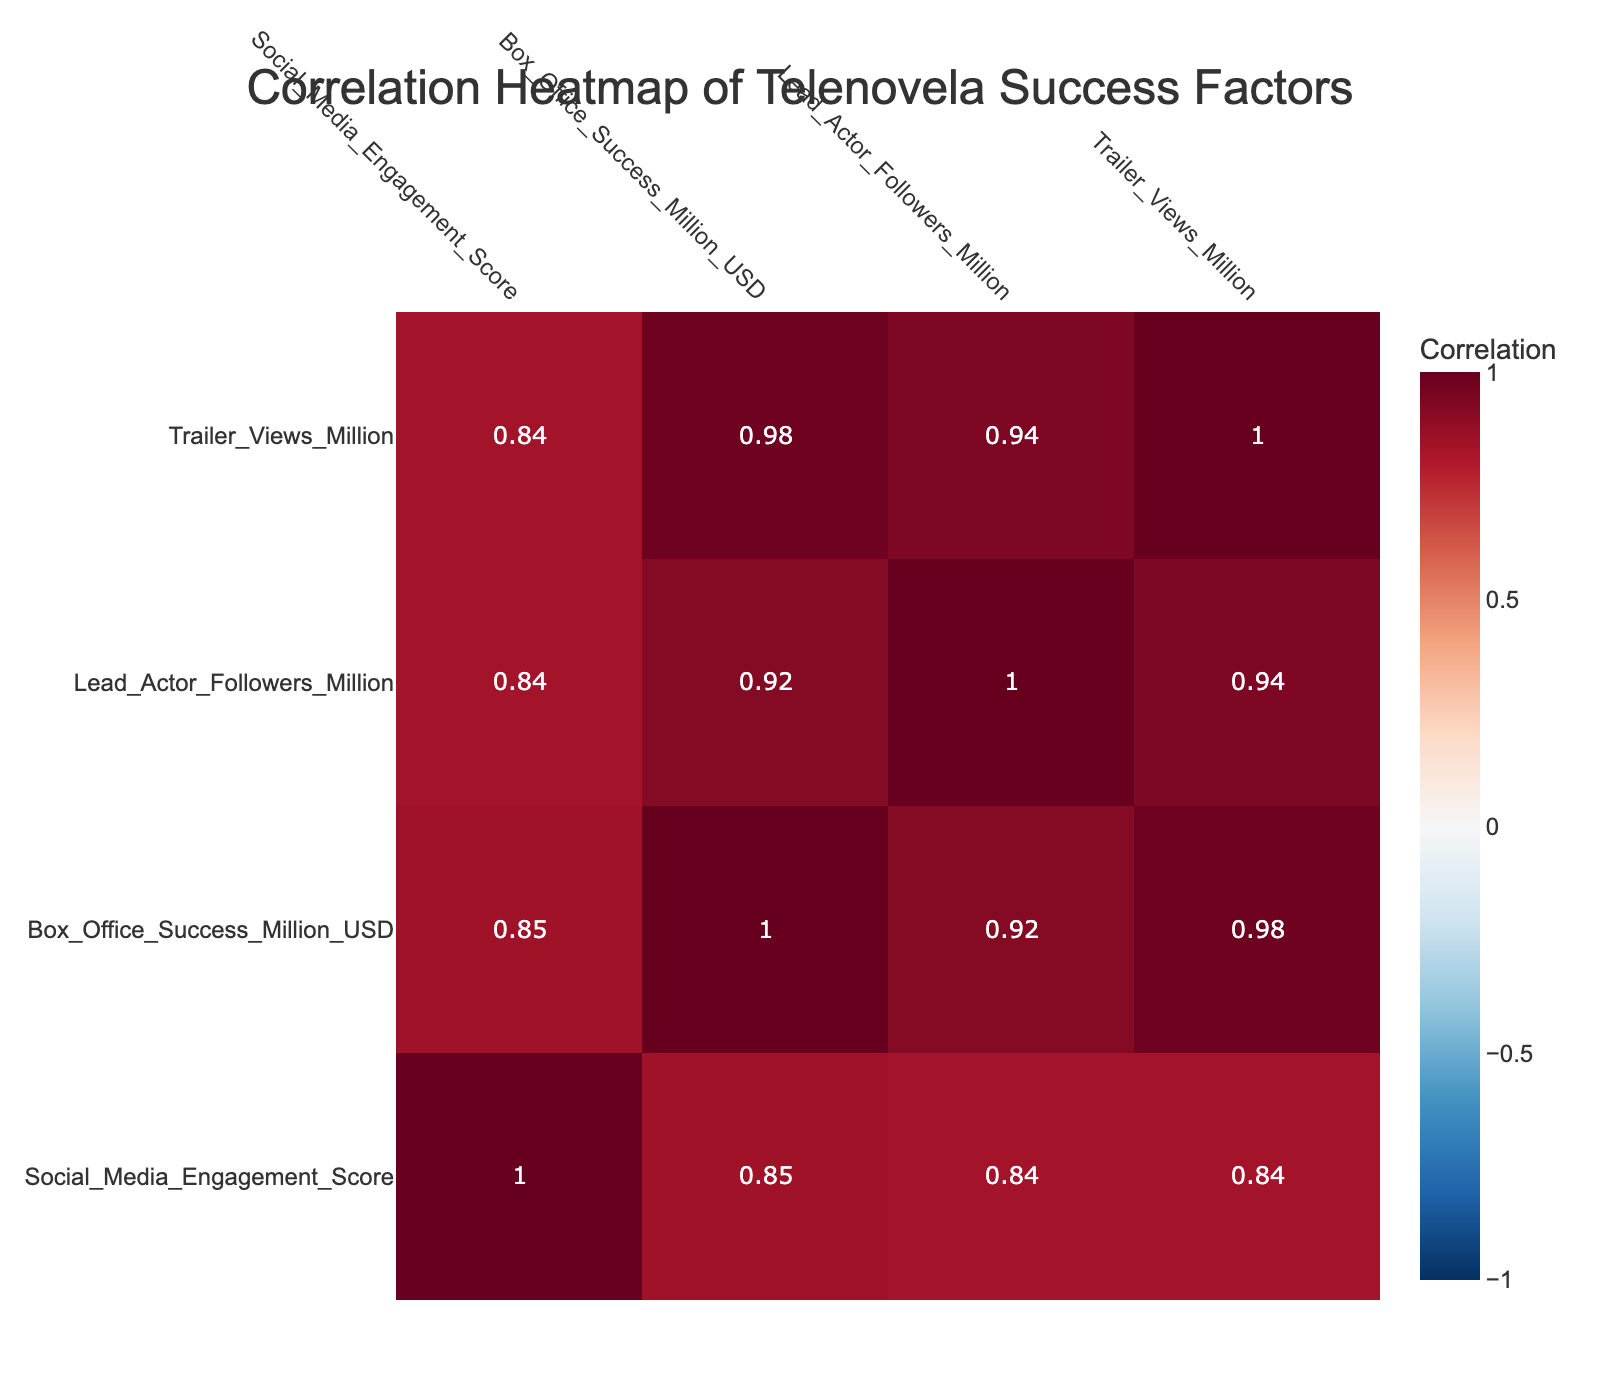What is the Box Office Success of "Amor Eterno"? From the table, we can look for the row corresponding to "Amor Eterno" and find the value under the "Box Office Success Million USD" column, which is 12.0.
Answer: 12.0 What is the correlation between Social Media Engagement Score and Box Office Success? To find the correlation between Social Media Engagement Score and Box Office Success, we observe the correlation matrix values, which shows a coefficient around 0.83. This indicates a strong positive correlation.
Answer: 0.83 Which telenovela has the highest Trailer Views? We compare the "Trailer Views Million" values for all telenovelas, and we see that "Bailando_en_La_Luna" has the highest value at 3.0 million views.
Answer: Bailando_en_La_Luna Is the correlation between Lead Actor Followers and Box Office Success positive? Referring to the correlation matrix, we can see the correlation coefficient between Lead Actor Followers and Box Office Success is 0.70, indicating a positive correlation.
Answer: Yes What is the average Social Media Engagement Score of all the telenovelas? We sum up the Social Media Engagement Scores of all telenovelas: 85 + 90 + 75 + 60 + 95 + 70 + 80 + 65 + 87 + 78 =  855. With 10 telenovelas, we divide 855 by 10 to find the average, which is 85.5.
Answer: 85.5 Which telenovela has the lowest Box Office Success, and what is that value? The telenovela with the lowest Box Office Success can be found by looking for the minimum in the "Box Office Success Million USD" column. The lowest value is 5.0 from "El_Destino".
Answer: El_Destino, 5.0 What is the difference in Box Office Success between the highest and lowest performing telenovela? The highest Box Office Success is from "Bailando_en_La_Luna" at 15.0 million and the lowest from "El_Destino" at 5.0 million. The difference is 15.0 - 5.0 = 10.0 million.
Answer: 10.0 Is the correlation between Social Media Engagement Score and Trailer Views closer to 0 or 1? By checking the correlation matrix, we find the value between Social Media Engagement Score and Trailer Views is 0.77, which is closer to 1, indicating a strong positive correlation.
Answer: Closer to 1 What is the range of Box Office Success scores? The highest Box Office Success is 15.0 in "Bailando_en_La_Luna" and the lowest is 5.0 in "El_Destino," so the range is 15.0 - 5.0 = 10.0 million.
Answer: 10.0 